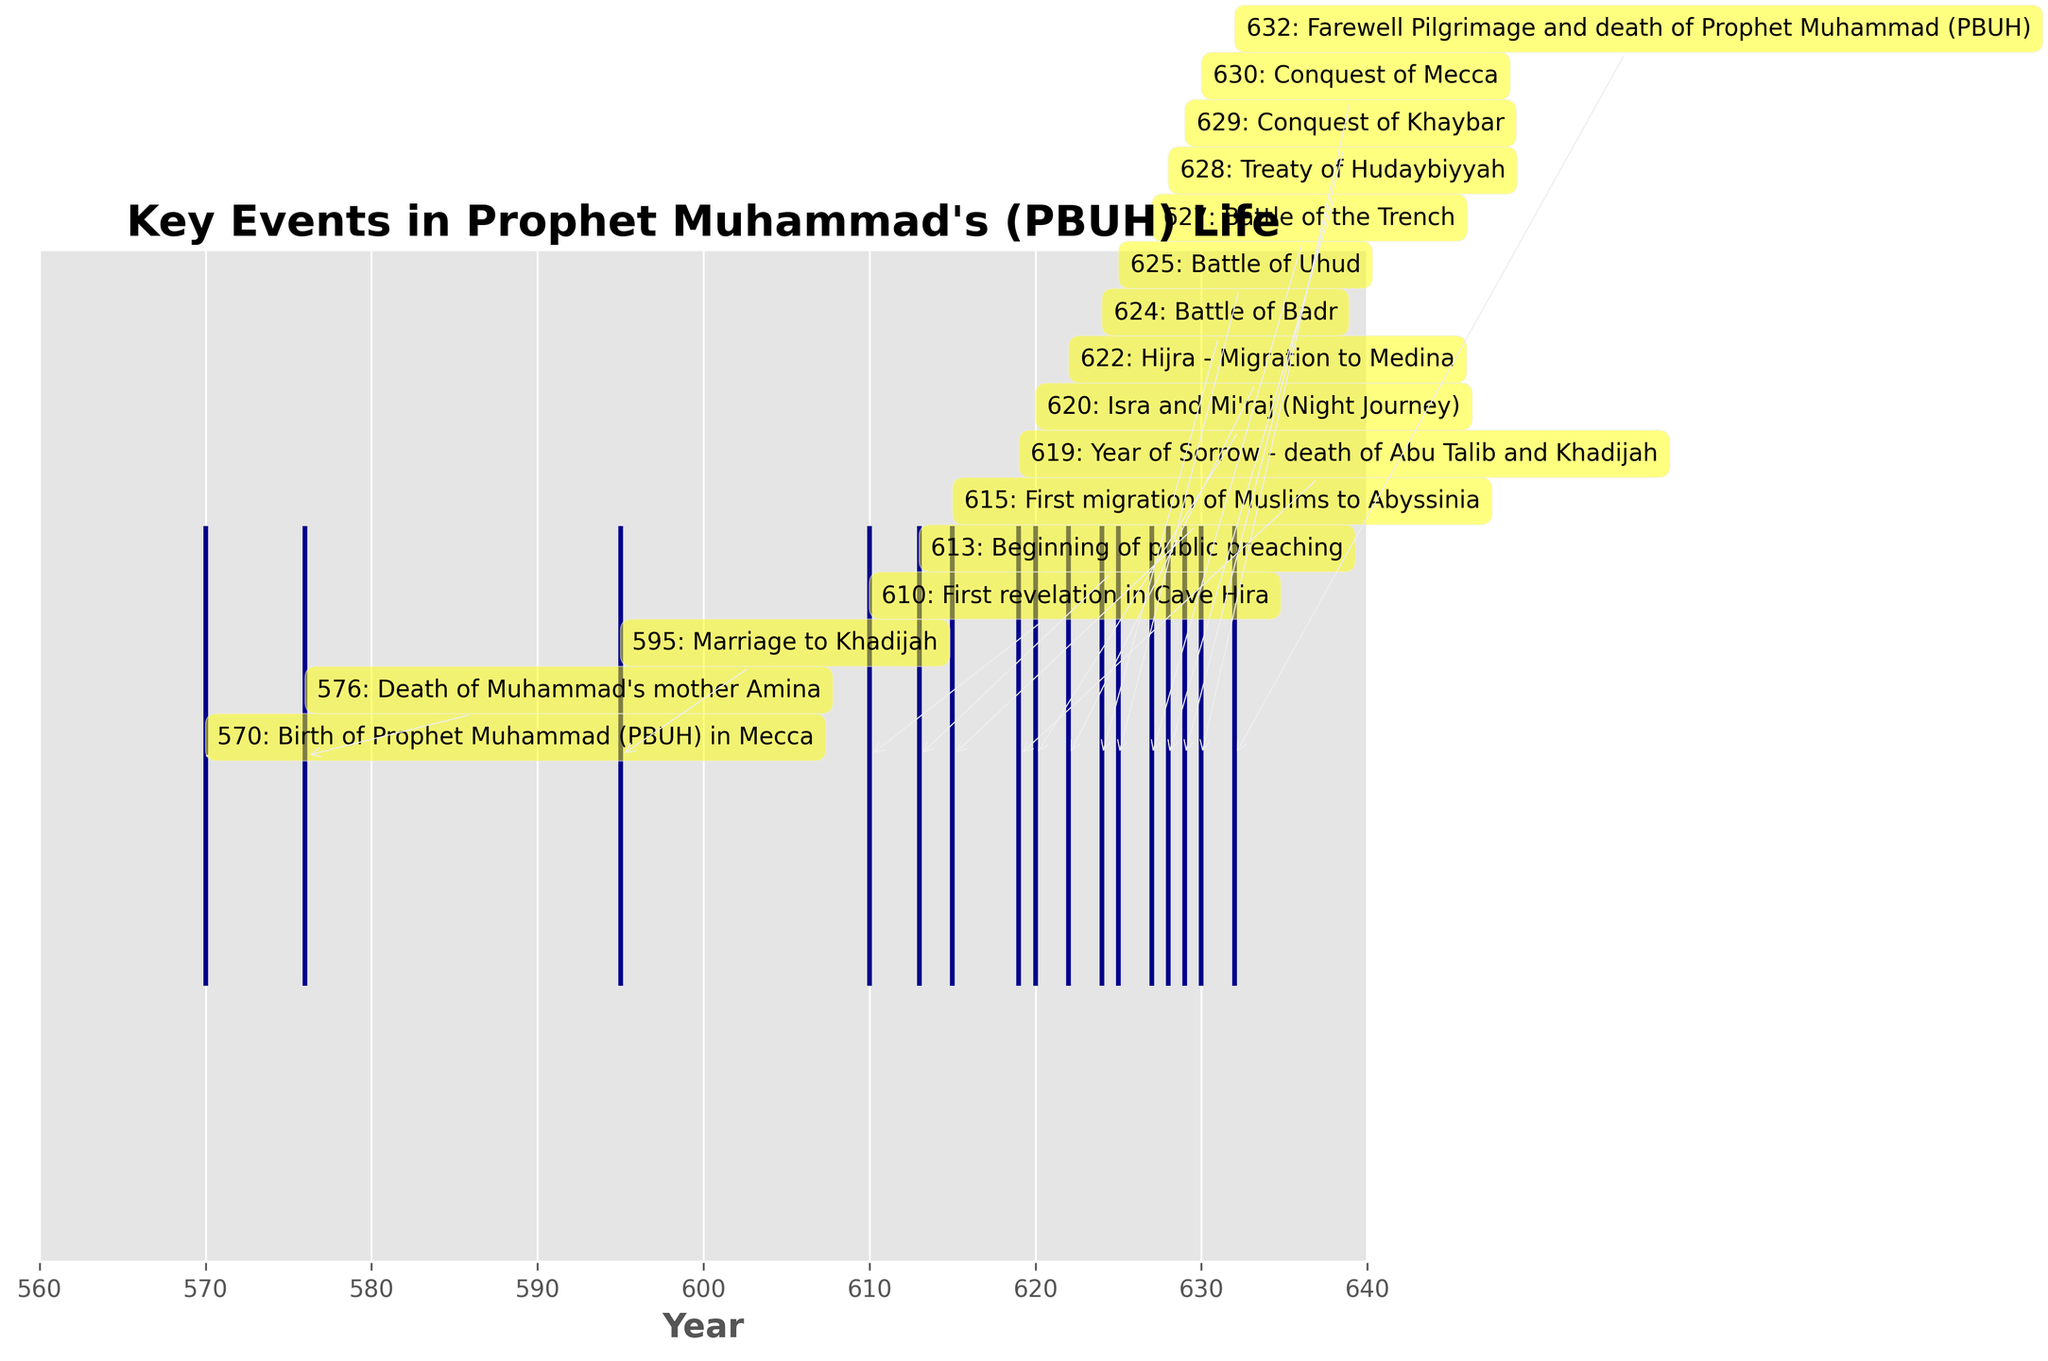How many key events are marked in the plot? Count the number of events labeled on the figure. These events are represented by the ticks on the horizontal axis.
Answer: 16 What is the title of the plot? Look at the top of the plot where the main heading is specified.
Answer: Key Events in Prophet Muhammad's (PBUH) Life What is the period with the highest frequency of key events? Observe the horizontal timeline and identify the range with the highest concentration of events.
Answer: 622-632 Which event occurred in the year 619? Find the label associated with the year 619 in the figure; it provides the event description.
Answer: Year of Sorrow - death of Abu Talib and Khadijah How many years after the birth of Prophet Muhammad (PBUH) did the first revelation occur? Subtract the year of birth (570) from the year of the first revelation (610).
Answer: 40 What was the first key event after the Hijra (Migration to Medina)? Look for the events labeled after the year 622, as Hijra occurred then. Identify the next chronological event.
Answer: Battle of Badr Among the Battles of Badr, Uhud, and the Trench, which occurred first? Compare the years for each of these battles: Badr in 624, Uhud in 625, and the Trench in 627.
Answer: Battle of Badr What event is marked in the year 632, and why is it significant? Identify the event labeled in the year 632. The year 632 is significant because it marks the end of Prophet Muhammad's (PBUH) life.
Answer: Farewell Pilgrimage and death of Prophet Muhammad (PBUH) How does the timing of the Treaty of Hudaybiyyah compare to the Conquest of Mecca? Identify the years for the Treaty of Hudaybiyyah (628) and the Conquest of Mecca (630) and compare which occurred first and by how many years.
Answer: Treaty of Hudaybiyyah occurred 2 years before Conquest of Mecca Which event in the timeline marks the beginning of public preaching? Find the label associated with the year 613, as public preaching began then.
Answer: Beginning of public preaching 